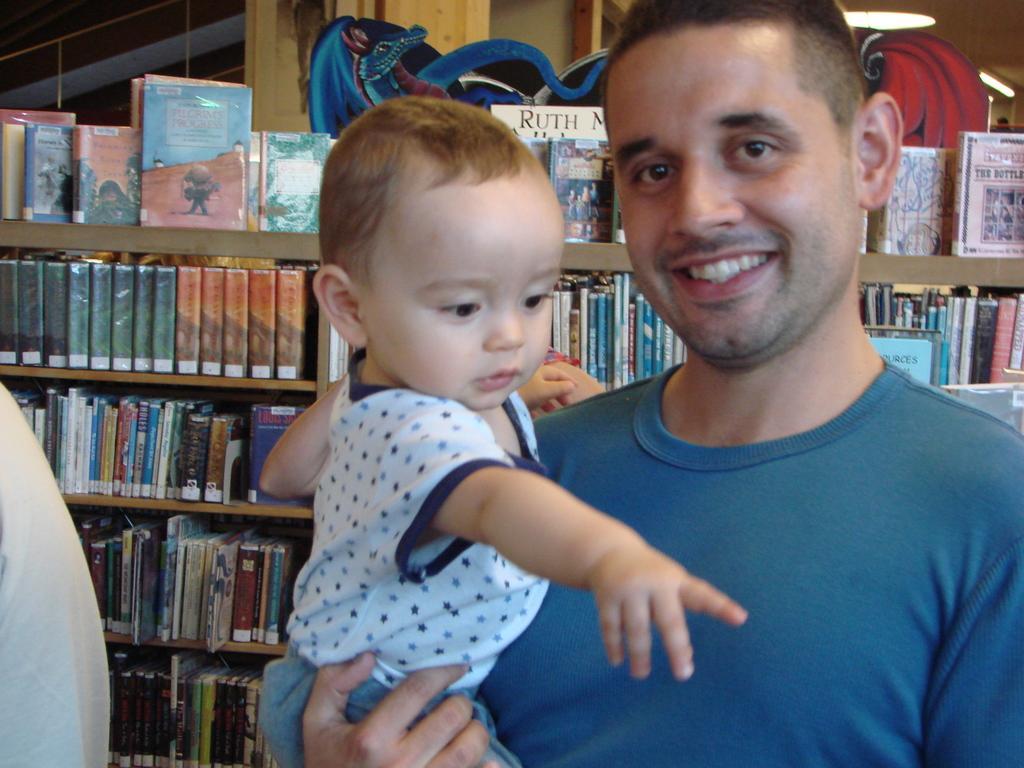Can you describe this image briefly? In this image there is a man standing. He is holding an infant in his hand. Behind him there are many books in the rack. In the top right there are lights to the ceiling. In the top left there is a railing. 